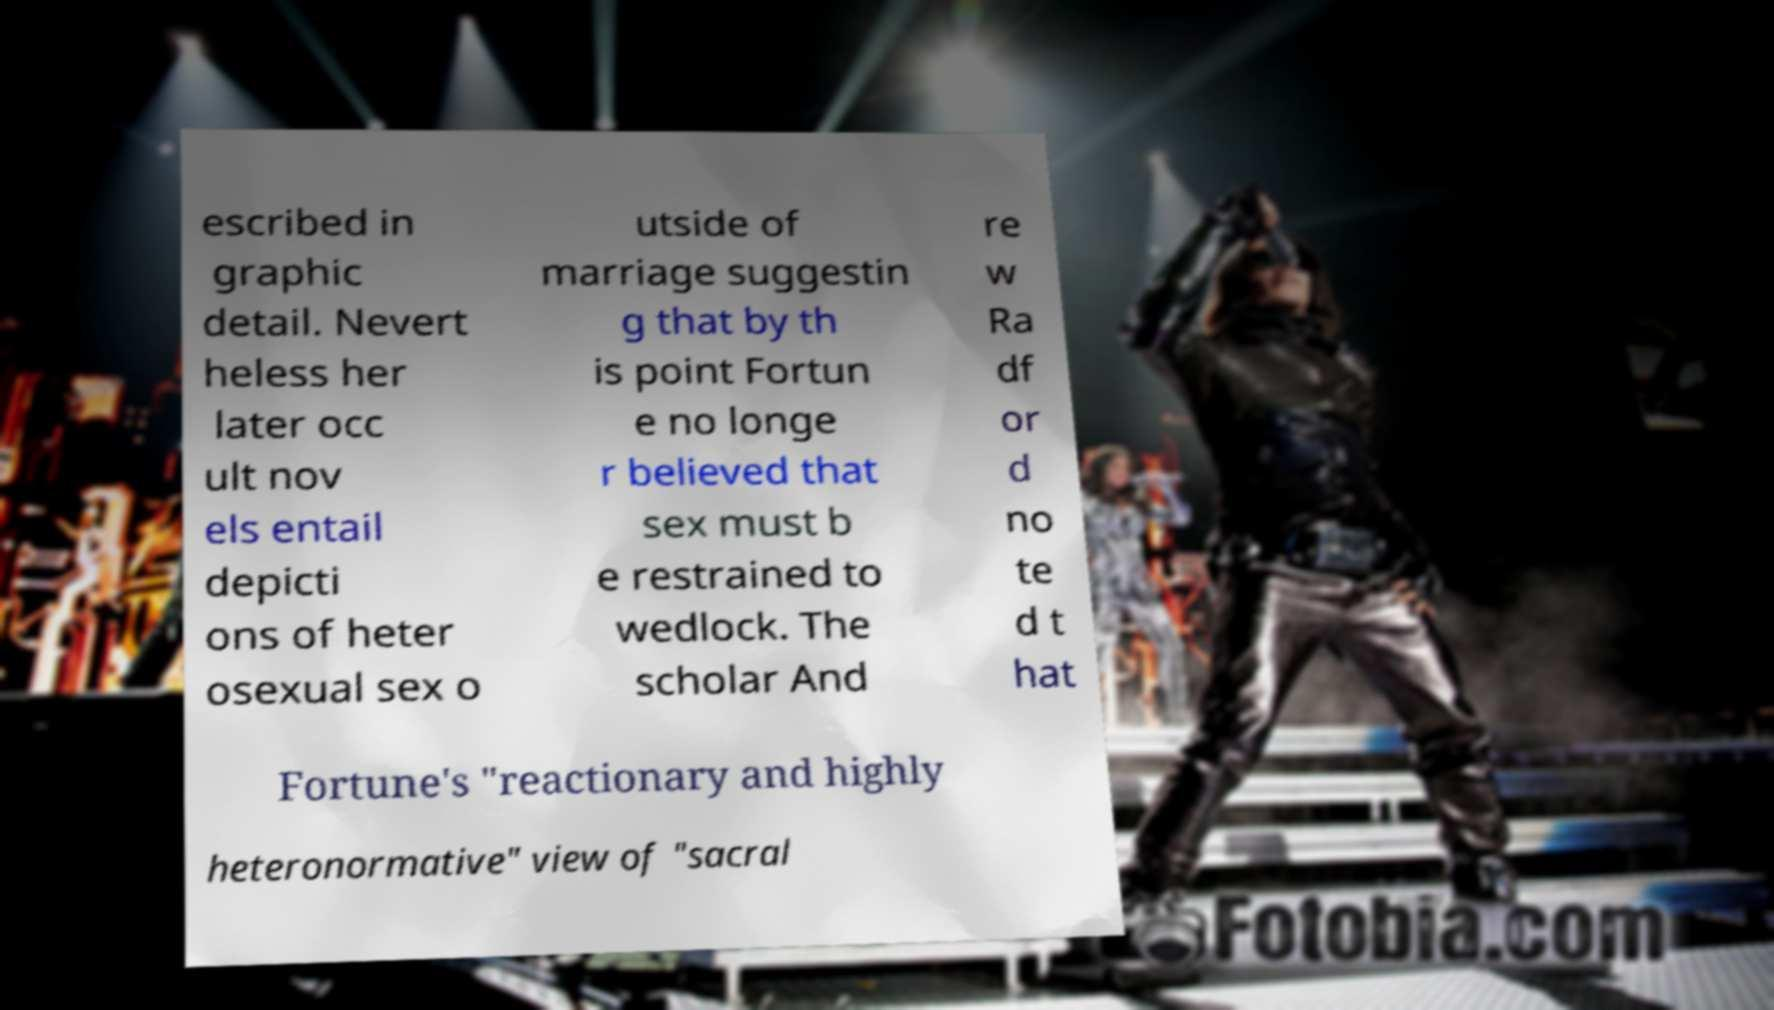What messages or text are displayed in this image? I need them in a readable, typed format. escribed in graphic detail. Nevert heless her later occ ult nov els entail depicti ons of heter osexual sex o utside of marriage suggestin g that by th is point Fortun e no longe r believed that sex must b e restrained to wedlock. The scholar And re w Ra df or d no te d t hat Fortune's "reactionary and highly heteronormative" view of "sacral 